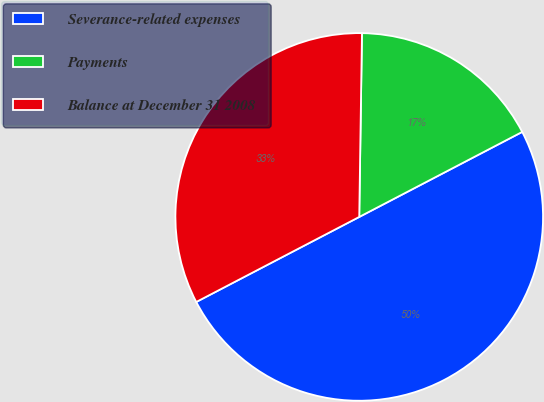Convert chart. <chart><loc_0><loc_0><loc_500><loc_500><pie_chart><fcel>Severance-related expenses<fcel>Payments<fcel>Balance at December 31 2008<nl><fcel>50.0%<fcel>17.11%<fcel>32.89%<nl></chart> 